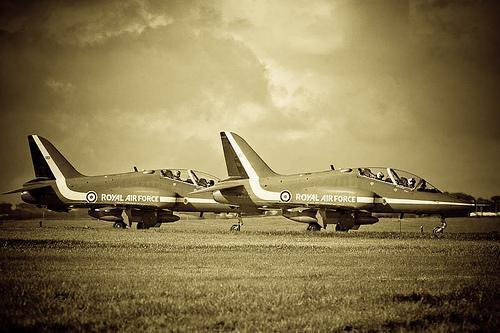How many planes are there?
Give a very brief answer. 2. 